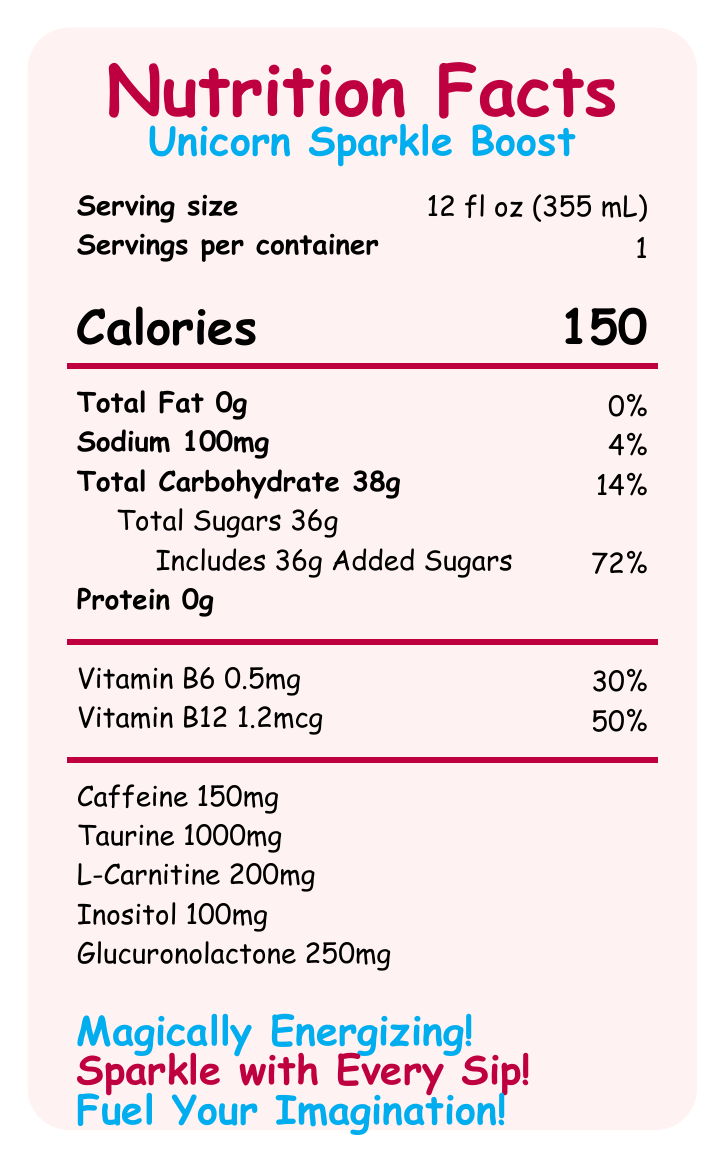what is the serving size? The serving size is explicitly mentioned in the document as "12 fl oz (355 mL)".
Answer: 12 fl oz (355 mL) how many calories are in one serving of Unicorn Sparkle Boost? The number of calories per serving is clearly stated as "150".
Answer: 150 calories what percentage of daily value is the added sugars? The document states that the added sugars (36g) have a daily value of 72%.
Answer: 72% how much caffeine is in Unicorn Sparkle Boost? The amount of caffeine is listed as "150mg" in the additional info section.
Answer: 150mg how much total carbohydrate is in one serving? The document states that the total carbohydrate per serving is 38g.
Answer: 38g what are the key ingredients of Unicorn Sparkle Boost? A. Sugar, Citric Acid, Taurine B. Ginger Extract, Citric Acid, Sucralose C. Carbonated Water, Natural Flavors, Spirulina The listed ingredients include "Carbonated Water, Sugar, Citric Acid, Natural and Artificial Flavors, Taurine," etc.
Answer: A. Sugar, Citric Acid, Taurine which vitamins are included in Unicorn Sparkle Boost? A. Vitamins A and C B. Vitamins D and K C. Vitamins B6 and B12 The document mentions that the drink includes "Vitamin B6" and "Vitamin B12".
Answer: C. Vitamins B6 and B12 can Unicorn Sparkle Boost be considered a source of protein? Unicorn Sparkle Boost contains 0g of protein, so it cannot be considered a source of protein.
Answer: No does Unicorn Sparkle Boost contain any fat? The document states that the drink has "Total Fat 0g", meaning it contains no fat.
Answer: No what is a potential allergen concern for Unicorn Sparkle Boost? The allergen info indicates that it is produced in a facility that processes milk and soy.
Answer: Milk and soy describe the overall benefits or main idea of Unicorn Sparkle Boost. The document highlights the drink as being energizing with added vitamins (B6 and B12), and containing no fat but a significant amount of sugar.
Answer: Unicorn Sparkle Boost is a magically energizing drink that sparkles with every sip, fueling your imagination with energy and vitamins while being free of fat and high in sugar content. how much of the daily value of Sodium does each serving of Unicorn Sparkle Boost provide? The document lists the sodium content as 100mg, which is 4% of the daily value.
Answer: 4% does Unicorn Sparkle Boost contain artificial colors? A. Yes B. No The ingredients list includes "Color Added (Blue #1, Red #40)", which are artificial colors.
Answer: A. Yes how much taurine is included in each serving of Unicorn Sparkle Boost? It is stated in the document that each serving contains "Taurine 1000mg".
Answer: 1000mg what is the purpose of Unicorn Sparkle Boost according to the marketing claims? The marketing claims such as "Magically Energizing!" and "Fuel Your Imagination!" suggest that the purpose is to energize and spark creativity.
Answer: To energize and spark the imagination what is the source of glucuronolactone in Unicorn Sparkle Boost? The document lists glucuronolactone as an ingredient but does not provide information on its source.
Answer: Not enough information 